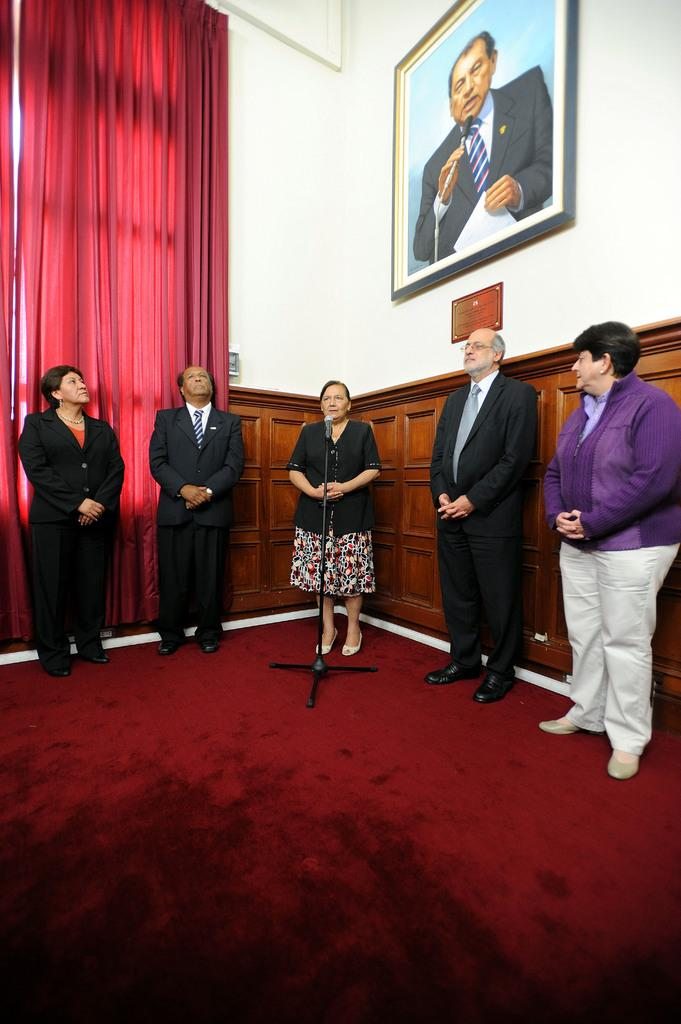What can be seen in the image? There are people standing in the image. Where are the people standing? The people are standing on the floor. What is the purpose of the microphone in the image? The microphone is placed in front of one of the people, suggesting that they may be speaking or singing. What can be seen in the background of the image? There are wall hangings and a curtain visible in the background. What type of knot is being tied by one of the people in the image? There is no knot-tying activity depicted in the image. What songs are being sung by the people in the image? The image does not provide information about the songs being sung by the people. 